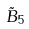Convert formula to latex. <formula><loc_0><loc_0><loc_500><loc_500>\tilde { B } _ { 5 }</formula> 